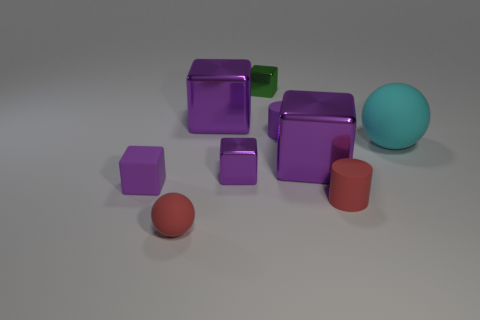The red sphere that is the same material as the small red cylinder is what size?
Ensure brevity in your answer.  Small. Is the color of the matte cube the same as the matte cylinder that is behind the cyan thing?
Keep it short and to the point. Yes. How many cyan objects are tiny balls or shiny blocks?
Provide a succinct answer. 0. The big matte thing is what shape?
Offer a very short reply. Sphere. What number of other things are the same shape as the cyan matte thing?
Offer a very short reply. 1. What color is the small block behind the cyan matte sphere?
Make the answer very short. Green. Does the cyan sphere have the same material as the green object?
Give a very brief answer. No. How many objects are green shiny objects or big purple metal things that are right of the tiny green thing?
Offer a very short reply. 2. There is a object that is the same color as the tiny matte ball; what size is it?
Your answer should be very brief. Small. There is a purple rubber thing that is in front of the cyan object; what is its shape?
Give a very brief answer. Cube. 